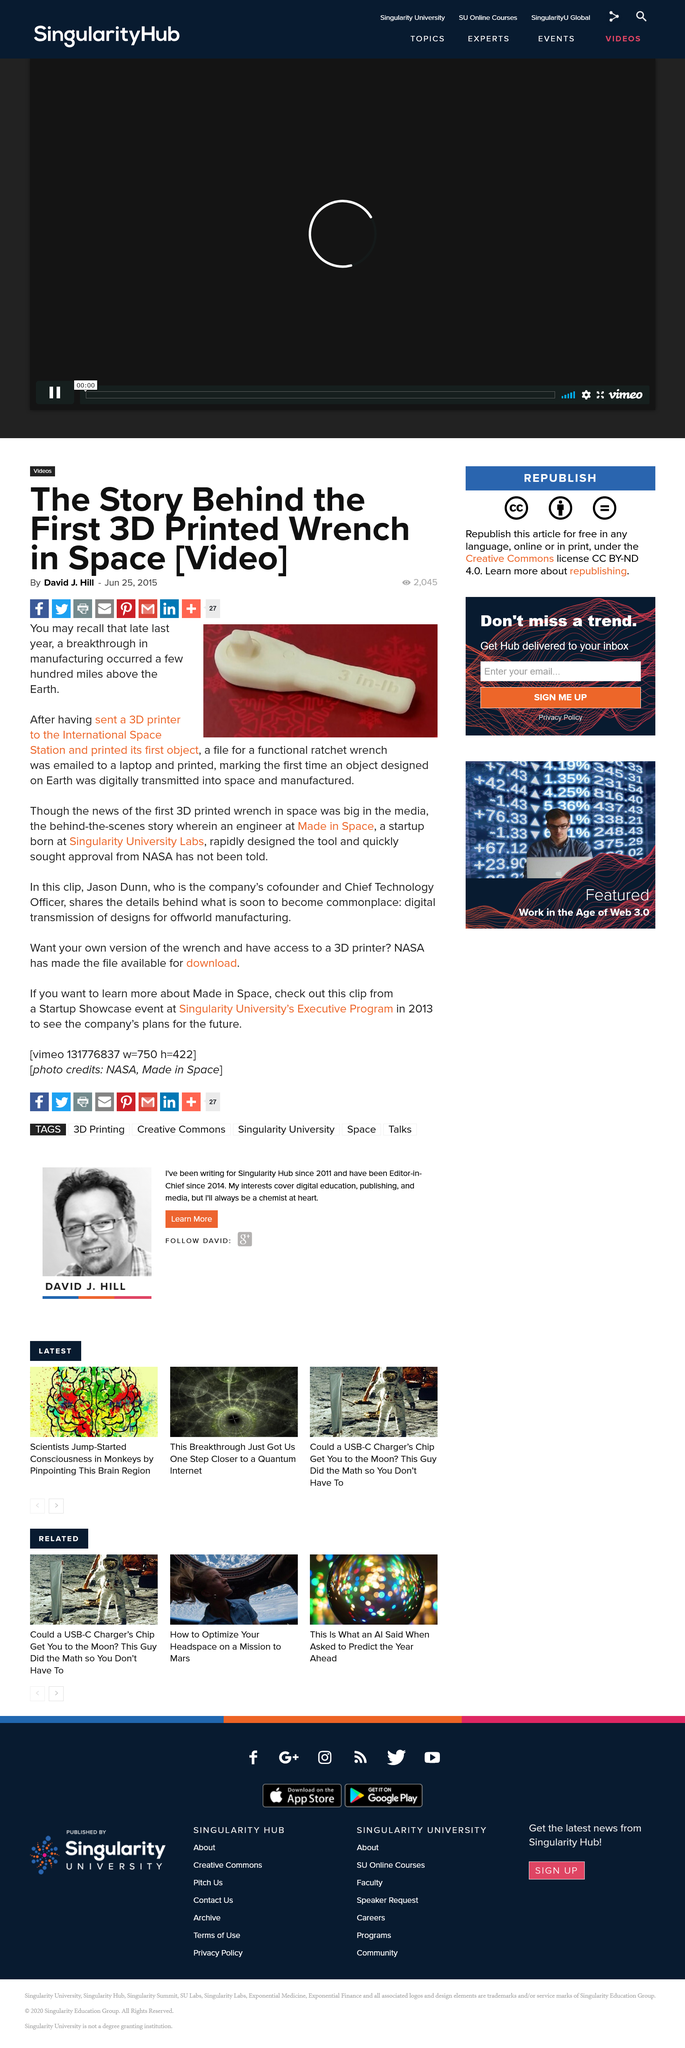Outline some significant characteristics in this image. In late 2014, a groundbreaking event occurred in the field of manufacturing, which took place several hundred miles above the Earth's surface. Jason Dunn is the cofounder and Chief Technology Officer of Made in Space, a company that specializes in space manufacturing technology. Made in Space is a startup that was born at Singularity University Labs. 